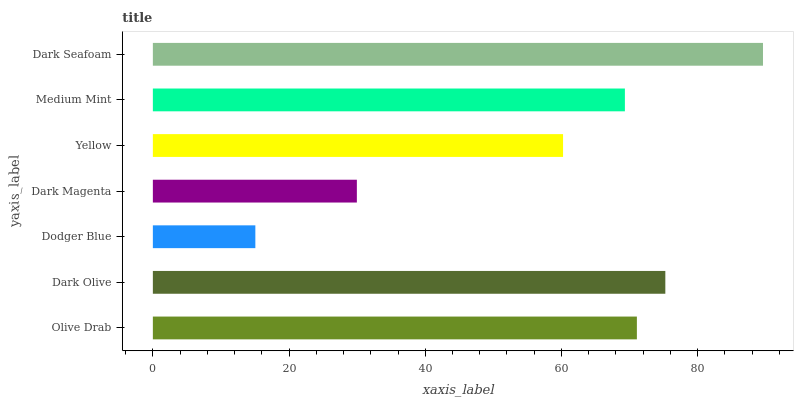Is Dodger Blue the minimum?
Answer yes or no. Yes. Is Dark Seafoam the maximum?
Answer yes or no. Yes. Is Dark Olive the minimum?
Answer yes or no. No. Is Dark Olive the maximum?
Answer yes or no. No. Is Dark Olive greater than Olive Drab?
Answer yes or no. Yes. Is Olive Drab less than Dark Olive?
Answer yes or no. Yes. Is Olive Drab greater than Dark Olive?
Answer yes or no. No. Is Dark Olive less than Olive Drab?
Answer yes or no. No. Is Medium Mint the high median?
Answer yes or no. Yes. Is Medium Mint the low median?
Answer yes or no. Yes. Is Dark Olive the high median?
Answer yes or no. No. Is Dark Olive the low median?
Answer yes or no. No. 